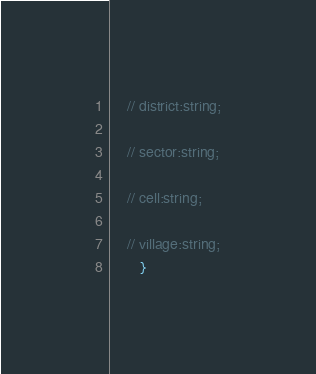Convert code to text. <code><loc_0><loc_0><loc_500><loc_500><_TypeScript_>    // district:string;
    
    // sector:string;
   
    // cell:string;
   
    // village:string;
       }</code> 